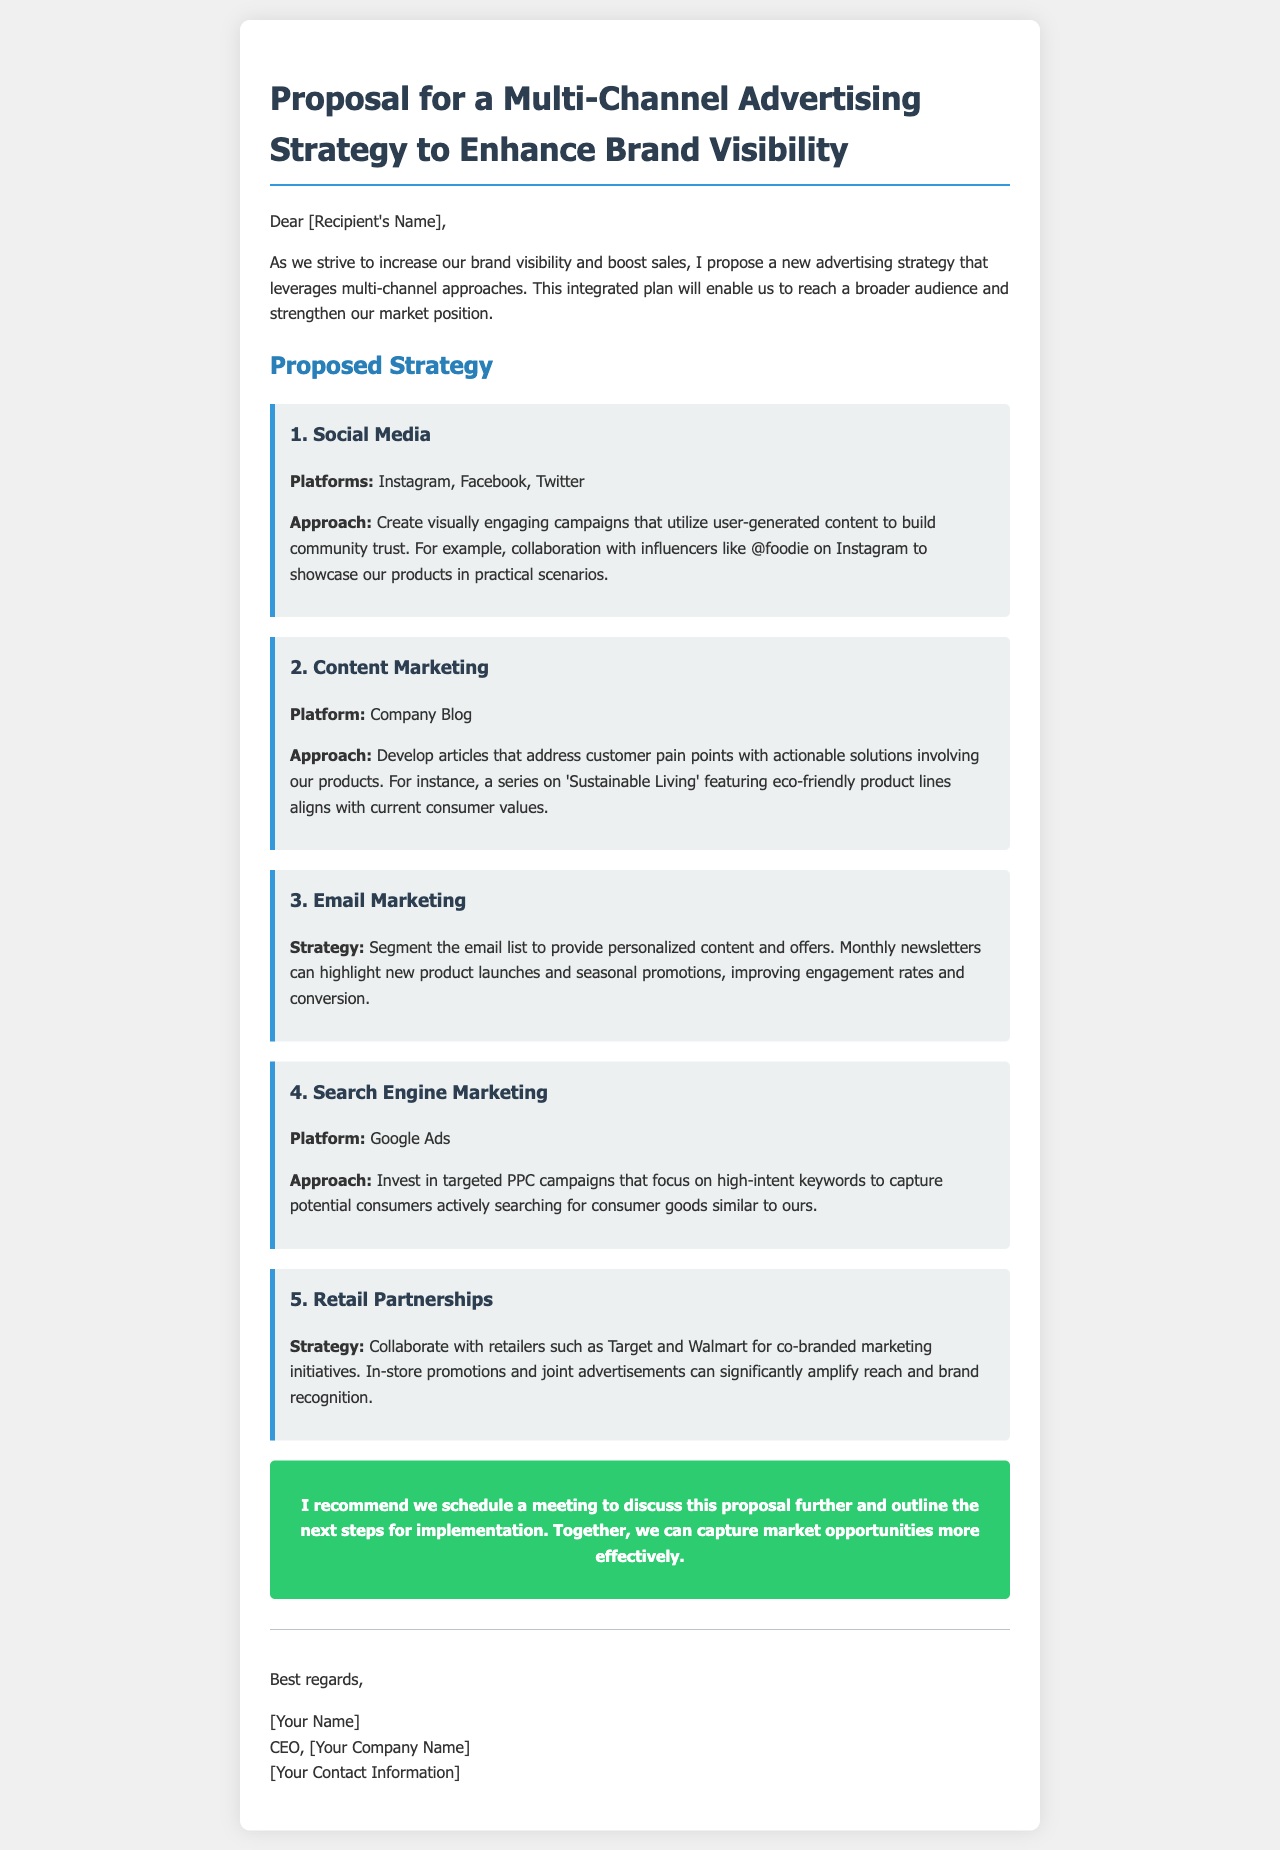What is the title of the proposal? The title is prominently stated at the beginning of the document.
Answer: Proposal for a Multi-Channel Advertising Strategy to Enhance Brand Visibility How many strategies are proposed in the document? The document lists a total of five distinct strategies under the "Proposed Strategy" section.
Answer: 5 Which social media platforms are mentioned in the proposal? The platforms are specified in the section discussing social media strategies.
Answer: Instagram, Facebook, Twitter What is one of the suggested approaches for content marketing? This approach is discussed in the content marketing section of the proposal.
Answer: Develop articles that address customer pain points What is the main goal of the proposed advertising strategy? The goal can be inferred from the introductory paragraph of the proposal.
Answer: Increase brand visibility and boost sales Who is recommended for collaboration in retail partnerships? The document mentions specific examples in the retail partnerships strategy.
Answer: Target and Walmart What is suggested for email marketing to improve engagement? This strategy is mentioned in the email marketing section of the proposal.
Answer: Segment the email list to provide personalized content What does the CTA recommend? The call-to-action section outlines the next steps for further discussion.
Answer: Schedule a meeting to discuss this proposal further 